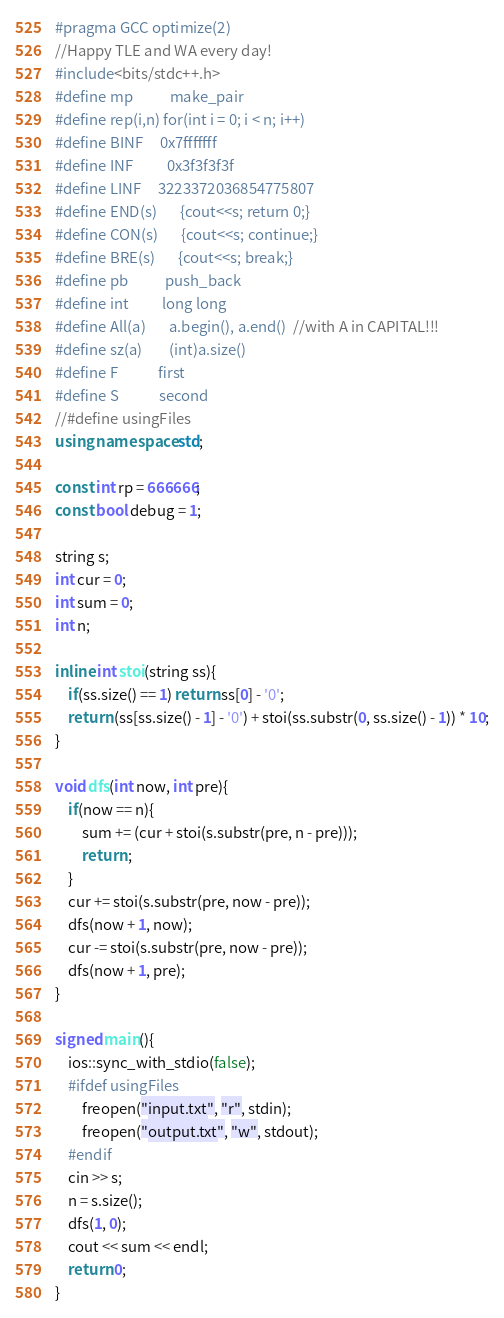Convert code to text. <code><loc_0><loc_0><loc_500><loc_500><_C++_>#pragma GCC optimize(2)
//Happy TLE and WA every day!
#include<bits/stdc++.h>
#define mp			make_pair
#define rep(i,n)	for(int i = 0; i < n; i++)
#define BINF		0x7fffffff
#define INF			0x3f3f3f3f
#define LINF		3223372036854775807
#define END(s)		{cout<<s; return 0;}
#define CON(s)		{cout<<s; continue;}
#define BRE(s)		{cout<<s; break;}
#define pb			push_back
#define int			long long
#define All(a)		a.begin(), a.end()  //with A in CAPITAL!!!
#define sz(a)		(int)a.size()
#define F			first
#define S			second
//#define usingFiles
using namespace std;

const int rp = 666666;
const bool debug = 1;

string s;
int cur = 0;
int sum = 0;
int n;

inline int stoi(string ss){
	if(ss.size() == 1) return ss[0] - '0';
	return (ss[ss.size() - 1] - '0') + stoi(ss.substr(0, ss.size() - 1)) * 10;
}

void dfs(int now, int pre){
	if(now == n){
		sum += (cur + stoi(s.substr(pre, n - pre)));
		return ;
	}
	cur += stoi(s.substr(pre, now - pre));
	dfs(now + 1, now);
	cur -= stoi(s.substr(pre, now - pre));
	dfs(now + 1, pre);
}

signed main(){
	ios::sync_with_stdio(false);
	#ifdef usingFiles
		freopen("input.txt", "r", stdin);
		freopen("output.txt", "w", stdout);
	#endif
	cin >> s;
	n = s.size();
	dfs(1, 0);
	cout << sum << endl;
	return 0;
}</code> 